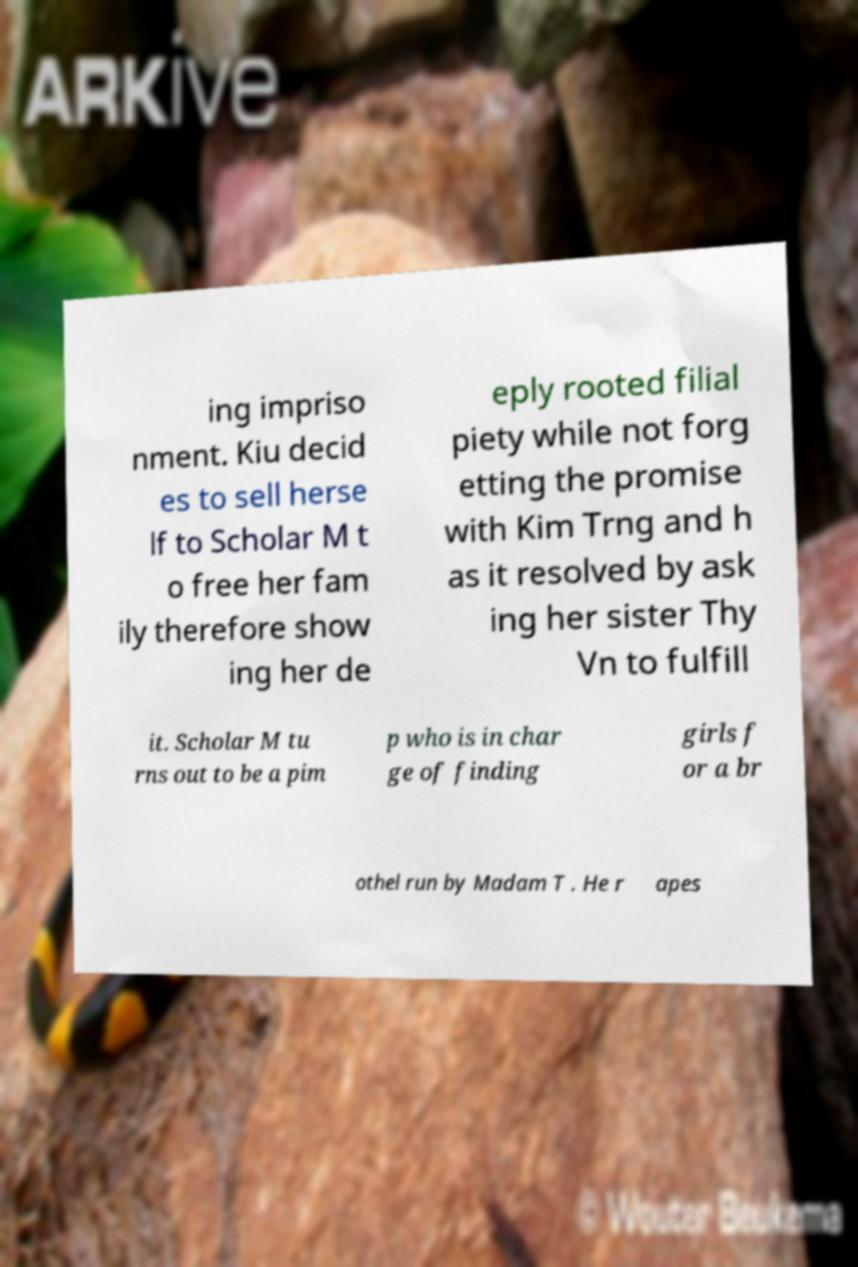What messages or text are displayed in this image? I need them in a readable, typed format. ing impriso nment. Kiu decid es to sell herse lf to Scholar M t o free her fam ily therefore show ing her de eply rooted filial piety while not forg etting the promise with Kim Trng and h as it resolved by ask ing her sister Thy Vn to fulfill it. Scholar M tu rns out to be a pim p who is in char ge of finding girls f or a br othel run by Madam T . He r apes 